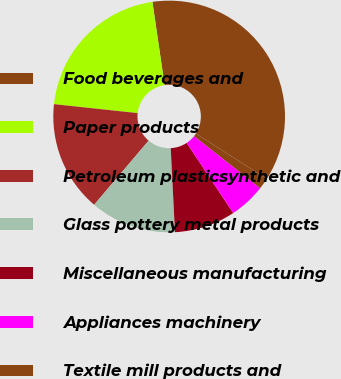Convert chart. <chart><loc_0><loc_0><loc_500><loc_500><pie_chart><fcel>Food beverages and<fcel>Paper products<fcel>Petroleum plasticsynthetic and<fcel>Glass pottery metal products<fcel>Miscellaneous manufacturing<fcel>Appliances machinery<fcel>Textile mill products and<nl><fcel>36.36%<fcel>20.99%<fcel>15.49%<fcel>12.01%<fcel>8.53%<fcel>5.05%<fcel>1.57%<nl></chart> 